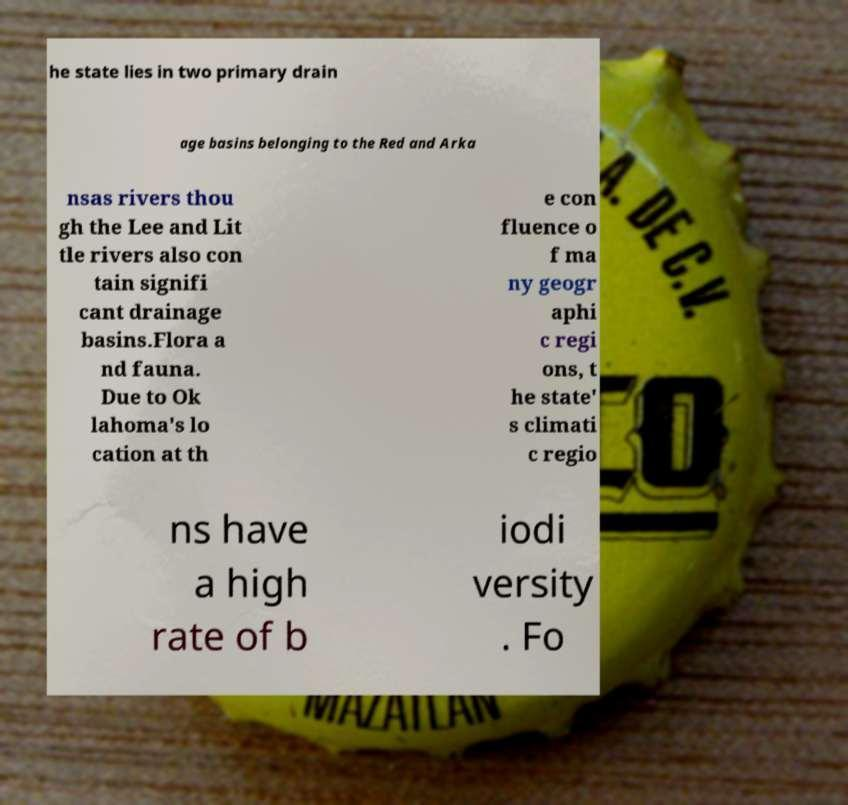Can you read and provide the text displayed in the image?This photo seems to have some interesting text. Can you extract and type it out for me? he state lies in two primary drain age basins belonging to the Red and Arka nsas rivers thou gh the Lee and Lit tle rivers also con tain signifi cant drainage basins.Flora a nd fauna. Due to Ok lahoma's lo cation at th e con fluence o f ma ny geogr aphi c regi ons, t he state' s climati c regio ns have a high rate of b iodi versity . Fo 